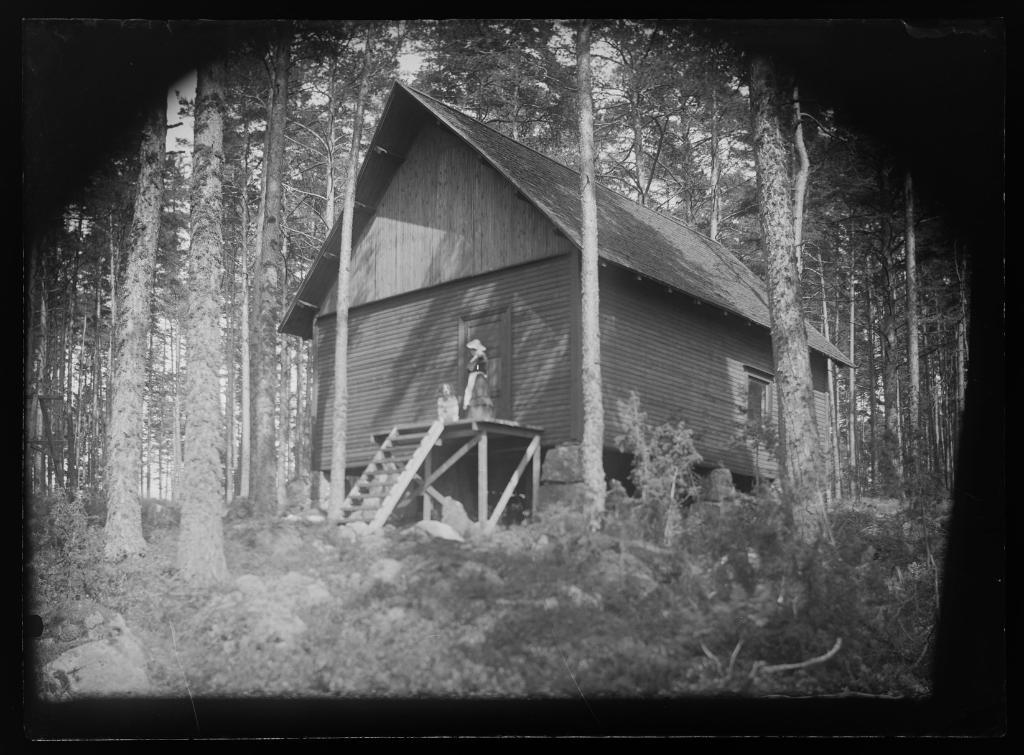What type of structure is present in the image? There is a hut in the image. What can be used to access the hut in the image? There is a ladder in the image that can be used to access the hut. How many people are in the image? There are two people in the image. What type of natural elements can be seen in the image? There are plants, rocks, and trees in the image. Can you tell me how many beetles are crawling on the trees in the image? There is no beetle present on the trees in the image; only the trees themselves are visible. What type of ornament is hanging from the roof of the hut in the image? There is no ornament hanging from the roof of the hut in the image. 